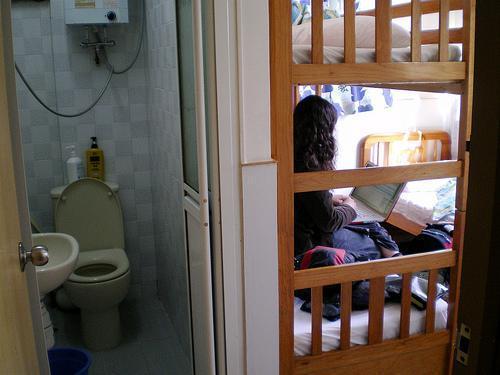How many people are in the photo?
Give a very brief answer. 1. How many beds are there?
Give a very brief answer. 3. 